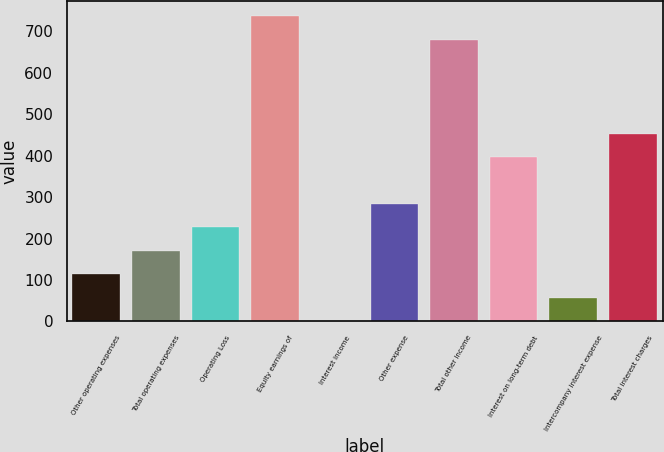<chart> <loc_0><loc_0><loc_500><loc_500><bar_chart><fcel>Other operating expenses<fcel>Total operating expenses<fcel>Operating Loss<fcel>Equity earnings of<fcel>Interest income<fcel>Other expense<fcel>Total other income<fcel>Interest on long-term debt<fcel>Intercompany interest expense<fcel>Total interest charges<nl><fcel>114<fcel>170.5<fcel>227<fcel>735.5<fcel>1<fcel>283.5<fcel>679<fcel>396.5<fcel>57.5<fcel>453<nl></chart> 